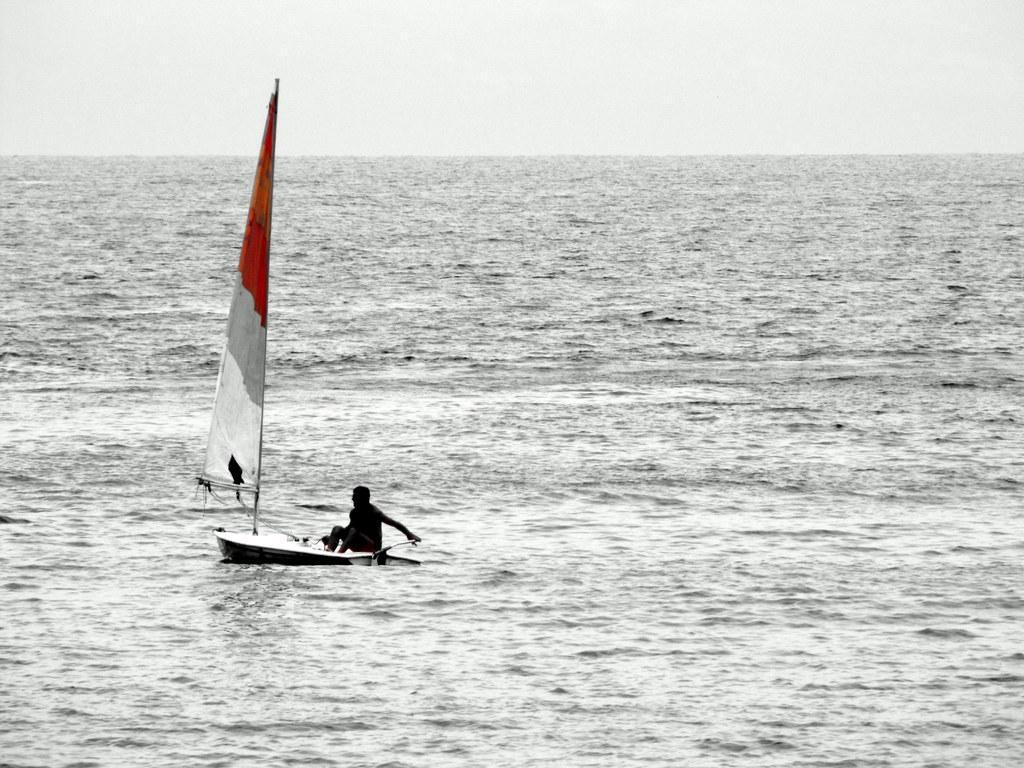In one or two sentences, can you explain what this image depicts? In this image there is the sky towards the top of the image, there is water towards the bottom of the image, there is a boat on the water, there is a man sitting on the boat, he is holding an object. 